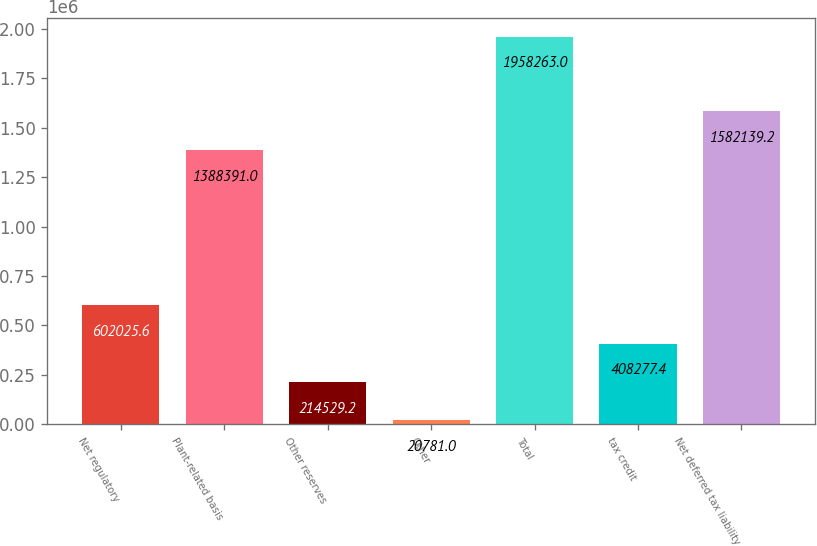Convert chart to OTSL. <chart><loc_0><loc_0><loc_500><loc_500><bar_chart><fcel>Net regulatory<fcel>Plant-related basis<fcel>Other reserves<fcel>Other<fcel>Total<fcel>tax credit<fcel>Net deferred tax liability<nl><fcel>602026<fcel>1.38839e+06<fcel>214529<fcel>20781<fcel>1.95826e+06<fcel>408277<fcel>1.58214e+06<nl></chart> 